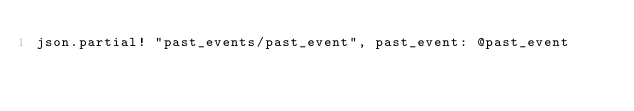<code> <loc_0><loc_0><loc_500><loc_500><_Ruby_>json.partial! "past_events/past_event", past_event: @past_event
</code> 